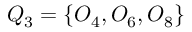<formula> <loc_0><loc_0><loc_500><loc_500>Q _ { 3 } = \{ O _ { 4 } , O _ { 6 } , O _ { 8 } \}</formula> 